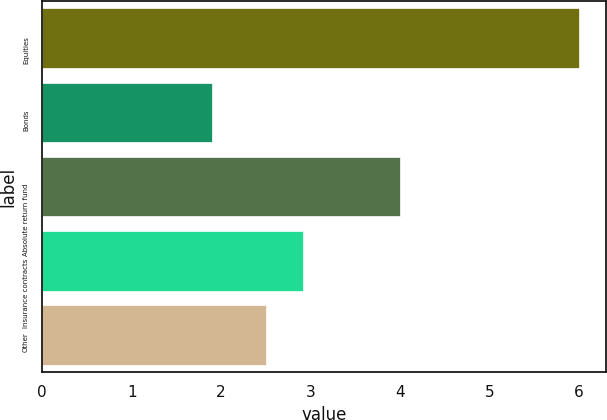Convert chart to OTSL. <chart><loc_0><loc_0><loc_500><loc_500><bar_chart><fcel>Equities<fcel>Bonds<fcel>Absolute return fund<fcel>Insurance contracts<fcel>Other<nl><fcel>6<fcel>1.9<fcel>4<fcel>2.91<fcel>2.5<nl></chart> 